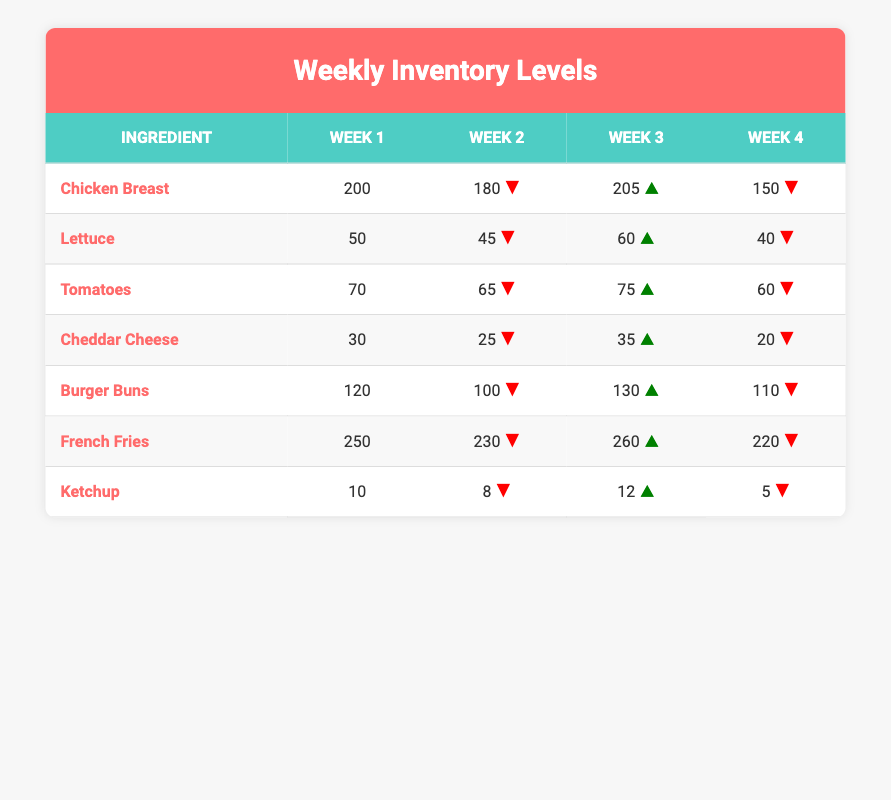What was the inventory level of Chicken Breast in Week 3? The table shows that the inventory level of Chicken Breast in Week 3 is 205.
Answer: 205 What is the trend in inventory for French Fries from Week 1 to Week 4? The inventory of French Fries decreased from 250 in Week 1 to 220 in Week 4, showing a downward trend overall.
Answer: Downward trend How many more Burger Buns were available in Week 3 compared to Week 2? The inventory level of Burger Buns in Week 3 is 130 and in Week 2 is 100. The difference is 130 - 100 = 30.
Answer: 30 Did the Lettuce inventory increase from Week 2 to Week 3? The inventory of Lettuce decreased from 45 in Week 2 to 60 in Week 3, indicating it did increase.
Answer: Yes What was the total inventory of Tomatoes over the four weeks? To find the total, we sum the inventory levels: 70 + 65 + 75 + 60 = 270.
Answer: 270 Was there a consistent increase in the inventory of Cheddar Cheese each week? The levels were 30, 25, 35, and 20, which shows fluctuation with no consistent increase.
Answer: No Which ingredient had the highest inventory in Week 1? The inventory levels in Week 1 were: Chicken Breast (200), Lettuce (50), Tomatoes (70), Cheddar Cheese (30), Burger Buns (120), French Fries (250), and Ketchup (10). The highest is French Fries at 250.
Answer: French Fries What is the average inventory of Ketchup over the four weeks? The Ketchup inventory is: 10, 8, 12, 5. The sum is 10 + 8 + 12 + 5 = 35. The average is 35/4 = 8.75.
Answer: 8.75 Between Week 1 and Week 4, what was the loss in inventory for Chicken Breast? The inventory levels were 200 in Week 1 and 150 in Week 4. The loss is 200 - 150 = 50.
Answer: 50 